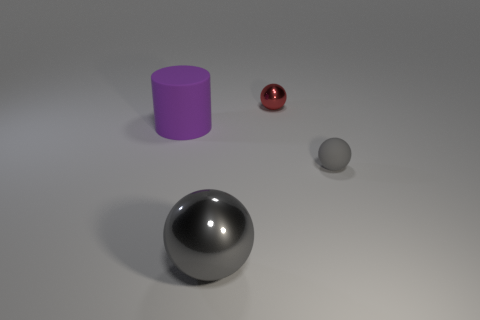Is the color of the big sphere the same as the tiny ball right of the small red metallic thing?
Your answer should be compact. Yes. Is the number of gray metallic things that are behind the gray matte ball less than the number of green shiny things?
Give a very brief answer. No. There is a sphere left of the red metal ball; what is its material?
Offer a very short reply. Metal. What number of other things are there of the same size as the matte ball?
Give a very brief answer. 1. Is the number of big balls less than the number of metal spheres?
Keep it short and to the point. Yes. The large purple thing has what shape?
Your answer should be very brief. Cylinder. Do the metal sphere that is left of the tiny red ball and the tiny matte sphere have the same color?
Offer a terse response. Yes. The object that is on the right side of the big gray metal ball and in front of the red thing has what shape?
Provide a succinct answer. Sphere. There is a cylinder behind the small matte ball; what is its color?
Offer a very short reply. Purple. Is there anything else that has the same color as the matte sphere?
Your response must be concise. Yes. 